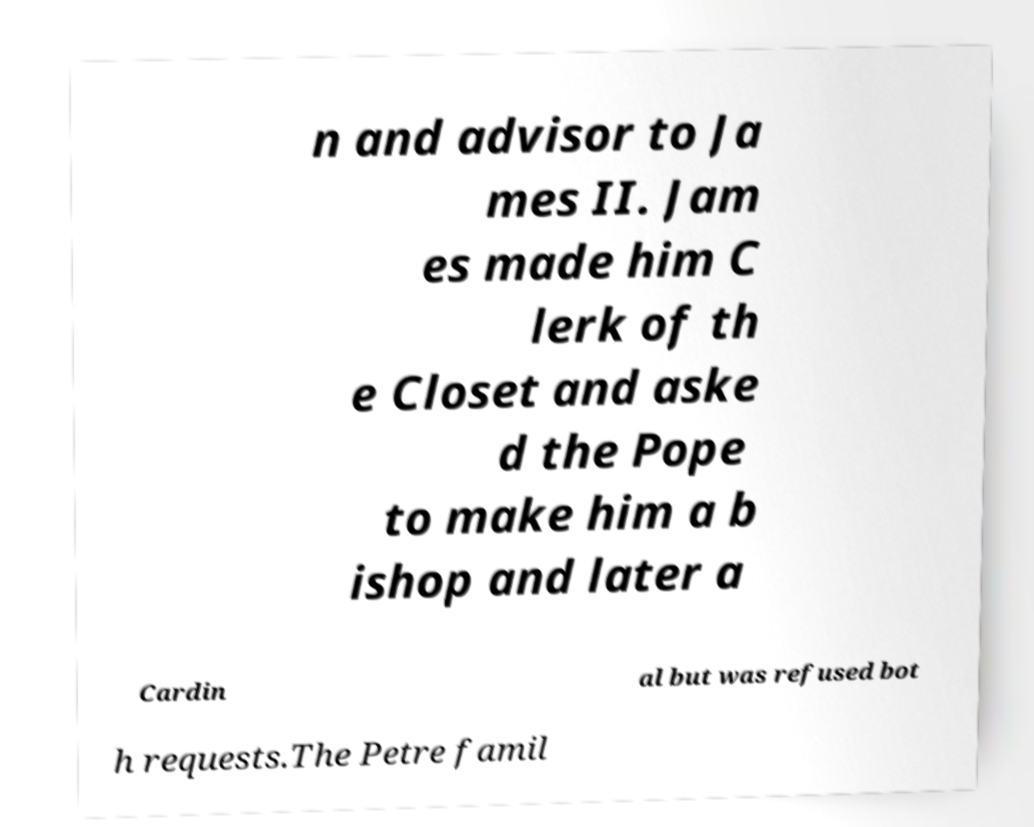Can you read and provide the text displayed in the image?This photo seems to have some interesting text. Can you extract and type it out for me? n and advisor to Ja mes II. Jam es made him C lerk of th e Closet and aske d the Pope to make him a b ishop and later a Cardin al but was refused bot h requests.The Petre famil 